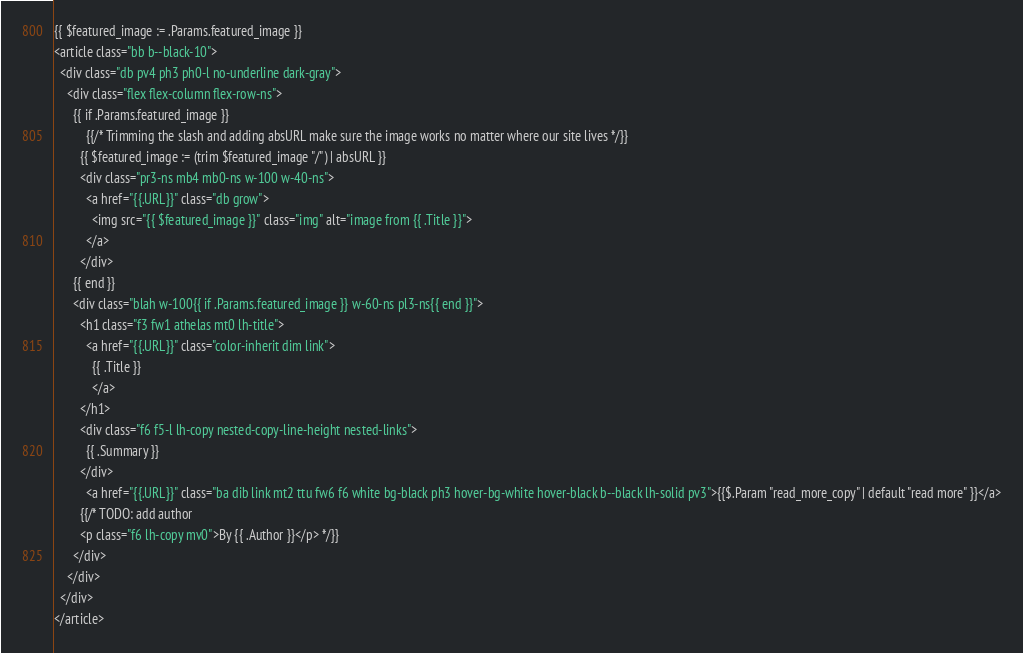Convert code to text. <code><loc_0><loc_0><loc_500><loc_500><_HTML_>{{ $featured_image := .Params.featured_image }}
<article class="bb b--black-10">
  <div class="db pv4 ph3 ph0-l no-underline dark-gray">
    <div class="flex flex-column flex-row-ns">
      {{ if .Params.featured_image }}
          {{/* Trimming the slash and adding absURL make sure the image works no matter where our site lives */}}
        {{ $featured_image := (trim $featured_image "/") | absURL }}
        <div class="pr3-ns mb4 mb0-ns w-100 w-40-ns">
          <a href="{{.URL}}" class="db grow">
            <img src="{{ $featured_image }}" class="img" alt="image from {{ .Title }}">
          </a>
        </div>
      {{ end }}
      <div class="blah w-100{{ if .Params.featured_image }} w-60-ns pl3-ns{{ end }}">
        <h1 class="f3 fw1 athelas mt0 lh-title">
          <a href="{{.URL}}" class="color-inherit dim link">
            {{ .Title }}
            </a>
        </h1>
        <div class="f6 f5-l lh-copy nested-copy-line-height nested-links">
          {{ .Summary }}
        </div>
          <a href="{{.URL}}" class="ba dib link mt2 ttu fw6 f6 white bg-black ph3 hover-bg-white hover-black b--black lh-solid pv3">{{$.Param "read_more_copy" | default "read more" }}</a>
        {{/* TODO: add author
        <p class="f6 lh-copy mv0">By {{ .Author }}</p> */}}
      </div>
    </div>
  </div>
</article>
</code> 